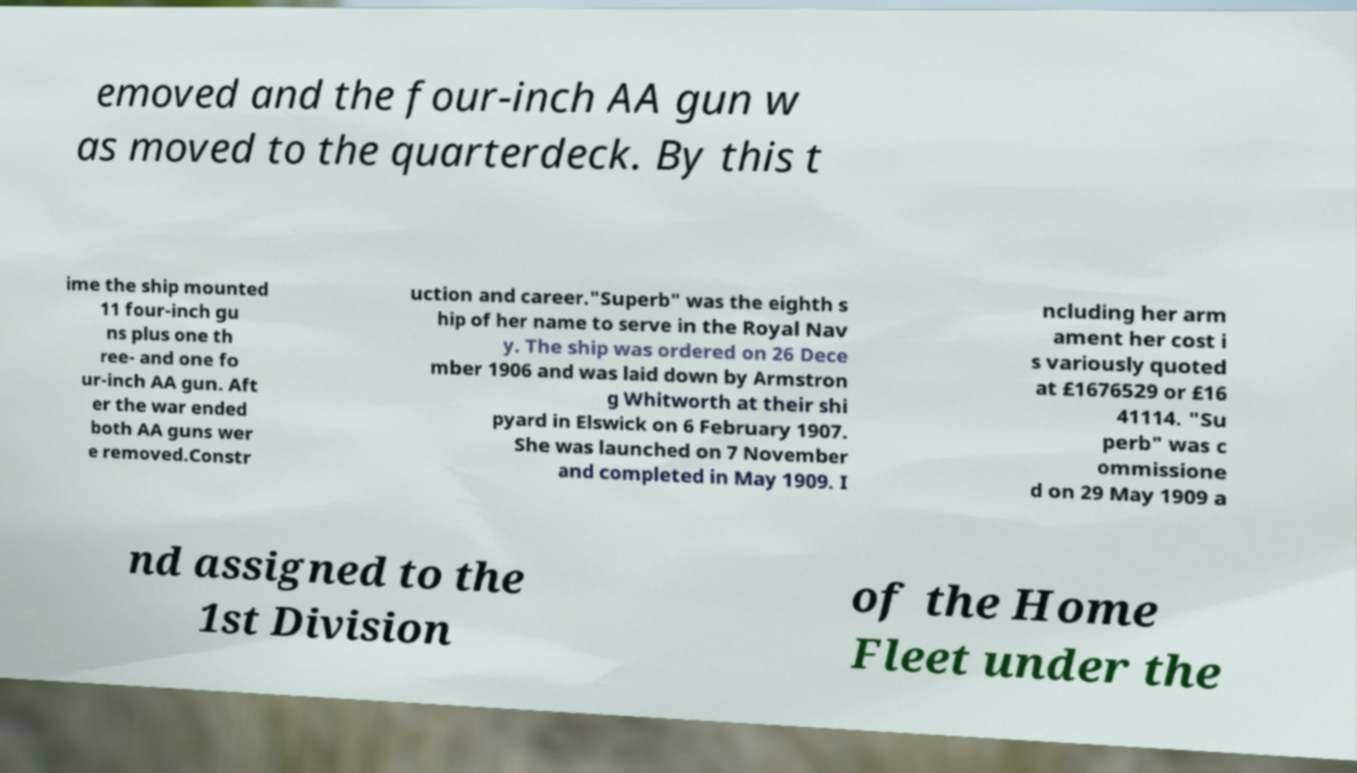For documentation purposes, I need the text within this image transcribed. Could you provide that? emoved and the four-inch AA gun w as moved to the quarterdeck. By this t ime the ship mounted 11 four-inch gu ns plus one th ree- and one fo ur-inch AA gun. Aft er the war ended both AA guns wer e removed.Constr uction and career."Superb" was the eighth s hip of her name to serve in the Royal Nav y. The ship was ordered on 26 Dece mber 1906 and was laid down by Armstron g Whitworth at their shi pyard in Elswick on 6 February 1907. She was launched on 7 November and completed in May 1909. I ncluding her arm ament her cost i s variously quoted at £1676529 or £16 41114. "Su perb" was c ommissione d on 29 May 1909 a nd assigned to the 1st Division of the Home Fleet under the 